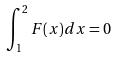Convert formula to latex. <formula><loc_0><loc_0><loc_500><loc_500>\int _ { 1 } ^ { 2 } F ( x ) d x = 0</formula> 